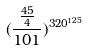<formula> <loc_0><loc_0><loc_500><loc_500>( \frac { \frac { 4 5 } { 4 } } { 1 0 1 } ) ^ { 3 2 0 ^ { 1 2 5 } }</formula> 